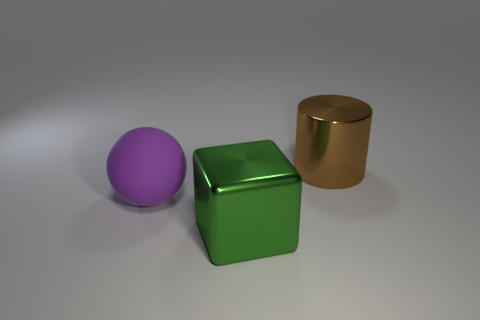What color is the thing that is on the right side of the purple matte thing and in front of the large brown shiny object?
Provide a short and direct response. Green. Is the size of the shiny thing that is left of the large cylinder the same as the shiny object behind the large rubber object?
Keep it short and to the point. Yes. How many things are either big metal objects left of the metallic cylinder or brown objects?
Make the answer very short. 2. What is the ball made of?
Provide a short and direct response. Rubber. What number of cylinders are green things or big purple matte things?
Offer a terse response. 0. The metal object that is behind the thing on the left side of the green thing is what color?
Offer a very short reply. Brown. Are there fewer balls behind the large cylinder than purple things on the right side of the green metal thing?
Offer a terse response. No. There is a metallic cylinder; is its size the same as the thing that is on the left side of the large green object?
Provide a short and direct response. Yes. What shape is the large thing that is both on the right side of the large purple sphere and behind the green thing?
Your response must be concise. Cylinder. How many objects are behind the large shiny thing that is left of the large brown metal cylinder?
Offer a very short reply. 2. 